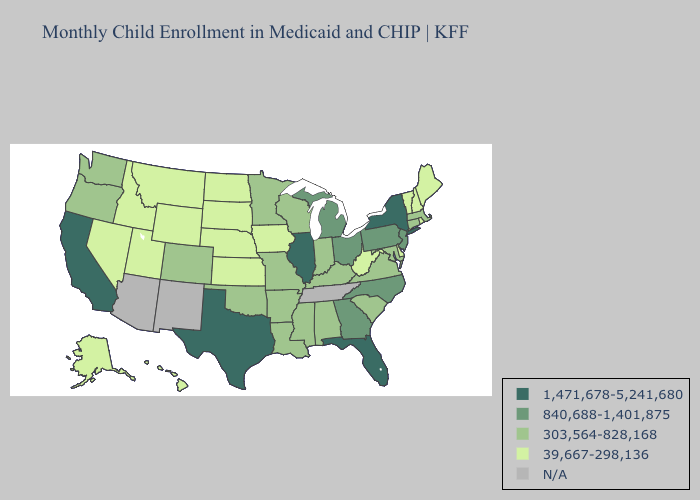Does North Carolina have the lowest value in the USA?
Answer briefly. No. Does Connecticut have the highest value in the Northeast?
Short answer required. No. Does New York have the highest value in the Northeast?
Answer briefly. Yes. What is the value of West Virginia?
Give a very brief answer. 39,667-298,136. What is the value of Montana?
Concise answer only. 39,667-298,136. What is the value of Alabama?
Be succinct. 303,564-828,168. Name the states that have a value in the range 1,471,678-5,241,680?
Be succinct. California, Florida, Illinois, New York, Texas. Among the states that border Utah , does Colorado have the lowest value?
Concise answer only. No. Name the states that have a value in the range 1,471,678-5,241,680?
Write a very short answer. California, Florida, Illinois, New York, Texas. What is the lowest value in the USA?
Keep it brief. 39,667-298,136. What is the value of Arkansas?
Be succinct. 303,564-828,168. Does the map have missing data?
Write a very short answer. Yes. What is the value of Mississippi?
Give a very brief answer. 303,564-828,168. 